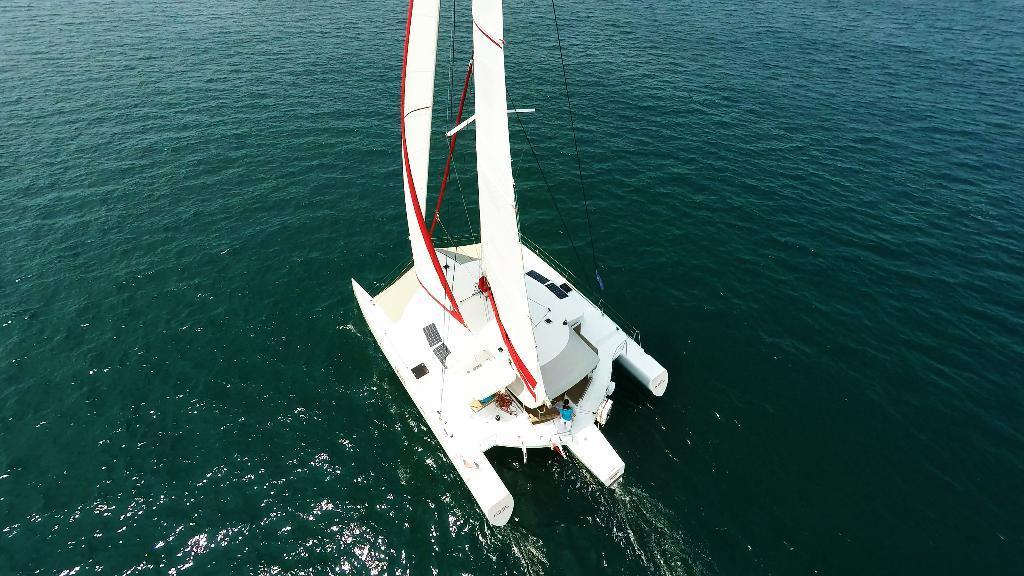Could you give a brief overview of what you see in this image? In this image I can see a ship which is white and red in color on the surface of the water which are green in color. I can see a person wearing blue shirt and white pant is standing on the ship. 